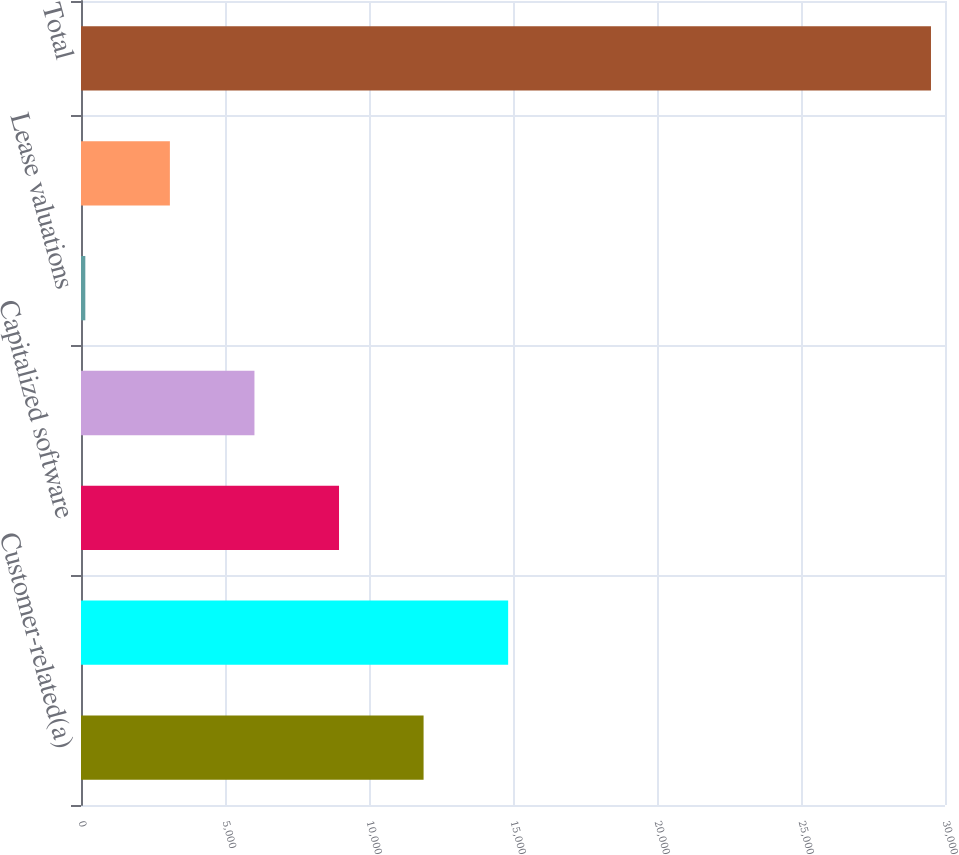<chart> <loc_0><loc_0><loc_500><loc_500><bar_chart><fcel>Customer-related(a)<fcel>Patents and technology<fcel>Capitalized software<fcel>Trademarks<fcel>Lease valuations<fcel>All other<fcel>Total<nl><fcel>11895.2<fcel>14831.5<fcel>8958.9<fcel>6022.6<fcel>150<fcel>3086.3<fcel>29513<nl></chart> 